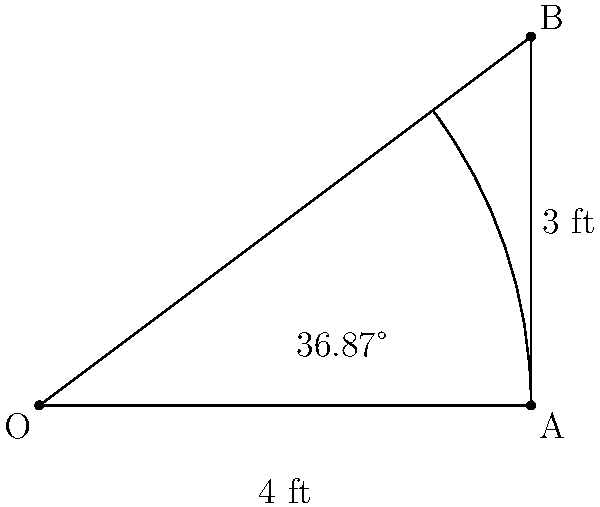During a Maryland Terrapins game, a player attempts a three-point shot from point B. If the distance from the basket (point O) to the three-point line (point A) is 4 feet, and the player is standing 3 feet behind the three-point line, what is the angle (in degrees) between the player's shot and the backboard? Let's approach this step-by-step:

1) We have a right triangle OAB, where:
   - OA is the distance from the basket to the three-point line (4 feet)
   - AB is the distance the player is behind the three-point line (3 feet)
   - OB is the hypotenuse, representing the direct distance from the player to the basket

2) We need to find angle BOA. We can do this using the inverse tangent function.

3) In a right triangle, tan(θ) = opposite / adjacent
   Here, tan(BOA) = AB / OA = 3 / 4

4) Therefore, angle BOA = arctan(3/4)

5) Using a calculator or programming function:
   arctan(3/4) ≈ 36.87 degrees

6) The angle between the player's shot and the backboard is this angle.

Thus, the angle between the player's shot and the backboard is approximately 36.87 degrees.
Answer: $36.87°$ 